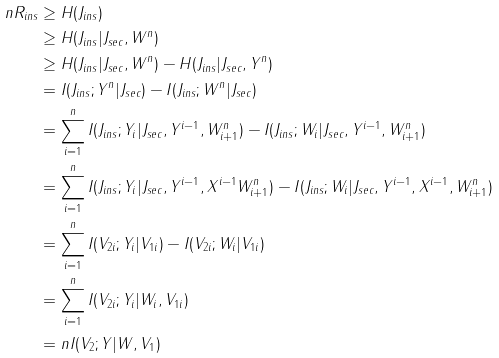Convert formula to latex. <formula><loc_0><loc_0><loc_500><loc_500>n R _ { i n s } & \geq H ( J _ { i n s } ) \\ & \geq H ( J _ { i n s } | J _ { s e c } , W ^ { n } ) \\ & \geq H ( J _ { i n s } | J _ { s e c } , W ^ { n } ) - H ( J _ { i n s } | J _ { s e c } , Y ^ { n } ) \\ & = I ( J _ { i n s } ; Y ^ { n } | J _ { s e c } ) - I ( J _ { i n s } ; W ^ { n } | J _ { s e c } ) \\ & = \sum _ { i = 1 } ^ { n } I ( J _ { i n s } ; Y _ { i } | J _ { s e c } , Y ^ { i - 1 } , W _ { i + 1 } ^ { n } ) - I ( J _ { i n s } ; W _ { i } | J _ { s e c } , Y ^ { i - 1 } , W _ { i + 1 } ^ { n } ) \\ & = \sum _ { i = 1 } ^ { n } I ( J _ { i n s } ; Y _ { i } | J _ { s e c } , Y ^ { i - 1 } , X ^ { i - 1 } W _ { i + 1 } ^ { n } ) - I ( J _ { i n s } ; W _ { i } | J _ { s e c } , Y ^ { i - 1 } , X ^ { i - 1 } , W _ { i + 1 } ^ { n } ) \\ & = \sum _ { i = 1 } ^ { n } I ( V _ { 2 i } ; Y _ { i } | V _ { 1 i } ) - I ( V _ { 2 i } ; W _ { i } | V _ { 1 i } ) \\ & = \sum _ { i = 1 } ^ { n } I ( V _ { 2 i } ; Y _ { i } | W _ { i } , V _ { 1 i } ) \\ & = n I ( V _ { 2 } ; Y | W , V _ { 1 } )</formula> 